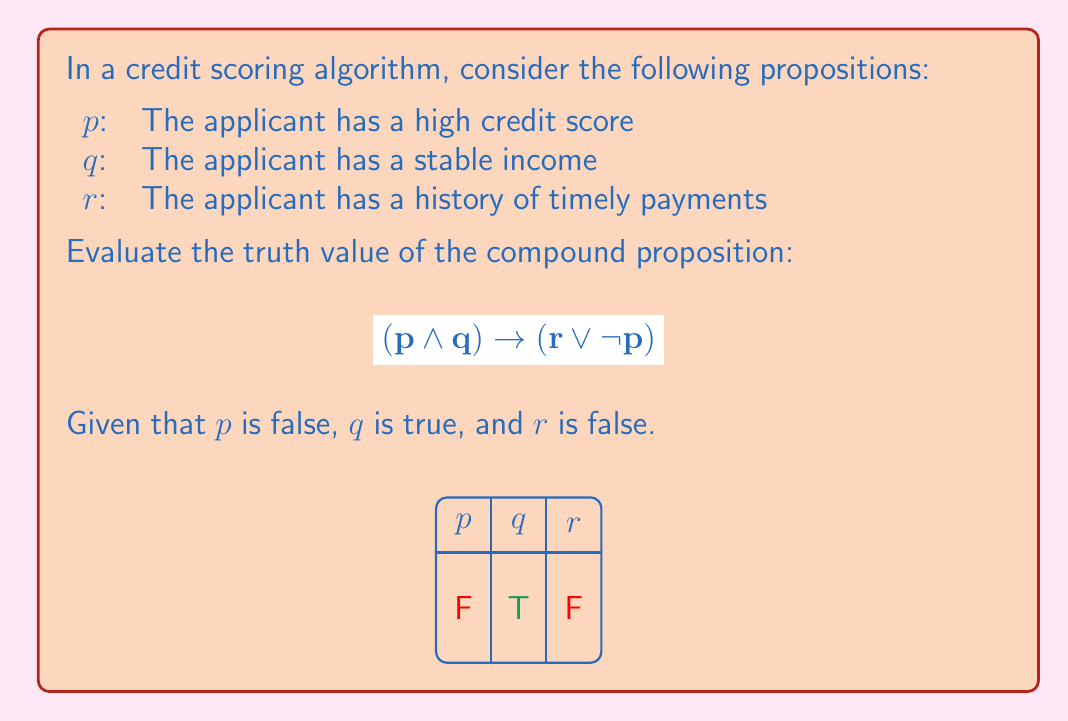Could you help me with this problem? Let's evaluate this compound proposition step-by-step:

1) First, we need to determine the truth values of each simple proposition:
   $p$ is false (F)
   $q$ is true (T)
   $r$ is false (F)

2) Now, let's evaluate the left side of the implication: $(p \land q)$
   $F \land T = F$
   The conjunction is false because $p$ is false.

3) Next, let's evaluate the right side of the implication: $(r \lor \neg p)$
   $\neg p$ is the negation of $p$. Since $p$ is false, $\neg p$ is true.
   $F \lor T = T$
   The disjunction is true because $\neg p$ is true.

4) Now we have the implication: $F \rightarrow T$

5) Recall the truth table for implication:
   F → F : T
   F → T : T
   T → F : F
   T → T : T

6) In our case, we have F → T, which is true according to the truth table.

Therefore, the entire compound proposition is true.
Answer: True 